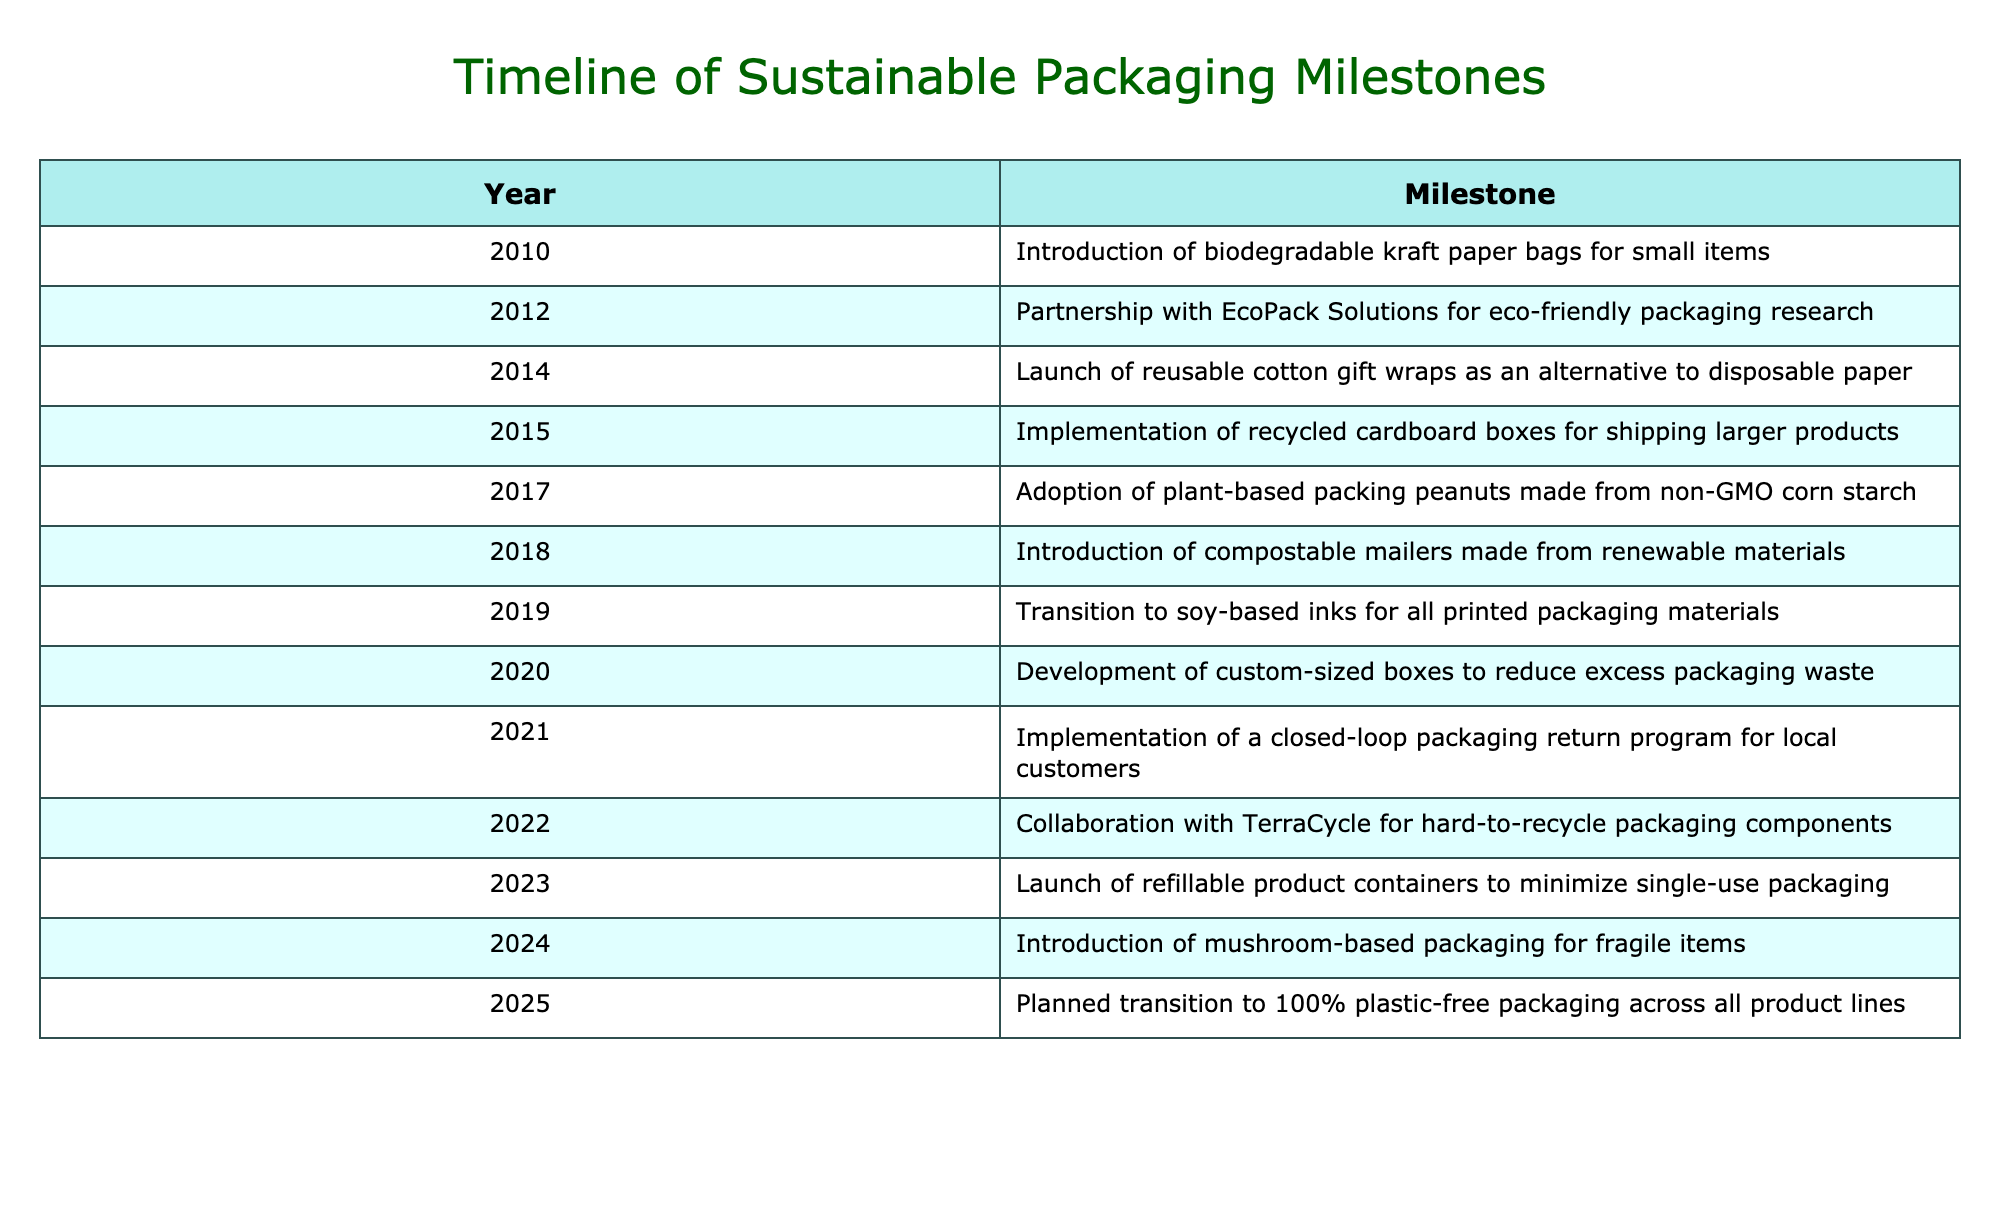What milestone was introduced in 2014? The table shows that in 2014, the milestone introduced was reusable cotton gift wraps as an alternative to disposable paper.
Answer: Reusable cotton gift wraps Which year saw the launch of compostable mailers? By examining the table, it indicates that compostable mailers made from renewable materials were introduced in 2018.
Answer: 2018 Was there a transition to soy-based inks before 2020? According to the table, the transition to soy-based inks occurred in 2019, which is indeed before 2020.
Answer: Yes How many years passed between the introduction of biodegradable kraft paper bags and the launch of refillable product containers? The introduction of biodegradable kraft paper bags occurred in 2010, and the launch of refillable product containers happened in 2023. The years can be calculated as 2023 - 2010 = 13 years.
Answer: 13 years What was the first sustainable packaging solution implemented according to the table? The first milestone listed in the table is the introduction of biodegradable kraft paper bags for small items in 2010, indicating it was the first solution implemented.
Answer: Biodegradable kraft paper bags In what year was there a partnership with EcoPack Solutions? Looking at the table, the partnership with EcoPack Solutions for eco-friendly packaging research was established in 2012.
Answer: 2012 Is it true that the company developed custom-sized boxes to reduce excess packaging waste in 2019? The table confirms that the development of custom-sized boxes to reduce excess packaging waste took place in 2020, not in 2019.
Answer: No How does the implementation of a closed-loop packaging return program relate to other initiatives in the timeline? The closed-loop packaging return program was implemented in 2021. It signifies an ongoing commitment to sustainability by allowing consumers to return packaging for reuse, aligning with earlier initiatives like the introduction of plant-based packing peanuts in 2017 and the collaboration with TerraCycle in 2022. This reflects a progressive trend in enhancing sustainability practices.
Answer: Implementation in 2021 reflects ongoing commitment to sustainability 